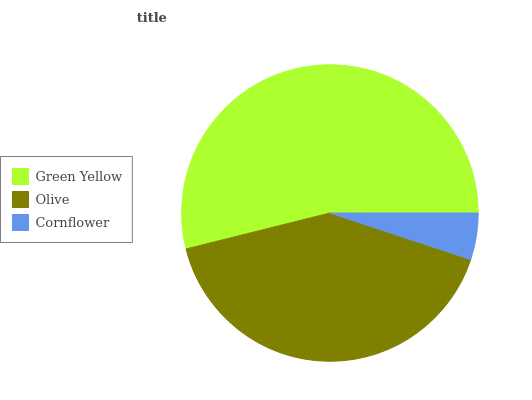Is Cornflower the minimum?
Answer yes or no. Yes. Is Green Yellow the maximum?
Answer yes or no. Yes. Is Olive the minimum?
Answer yes or no. No. Is Olive the maximum?
Answer yes or no. No. Is Green Yellow greater than Olive?
Answer yes or no. Yes. Is Olive less than Green Yellow?
Answer yes or no. Yes. Is Olive greater than Green Yellow?
Answer yes or no. No. Is Green Yellow less than Olive?
Answer yes or no. No. Is Olive the high median?
Answer yes or no. Yes. Is Olive the low median?
Answer yes or no. Yes. Is Green Yellow the high median?
Answer yes or no. No. Is Cornflower the low median?
Answer yes or no. No. 